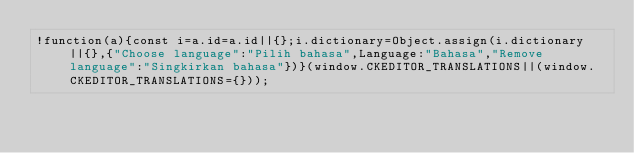Convert code to text. <code><loc_0><loc_0><loc_500><loc_500><_JavaScript_>!function(a){const i=a.id=a.id||{};i.dictionary=Object.assign(i.dictionary||{},{"Choose language":"Pilih bahasa",Language:"Bahasa","Remove language":"Singkirkan bahasa"})}(window.CKEDITOR_TRANSLATIONS||(window.CKEDITOR_TRANSLATIONS={}));</code> 